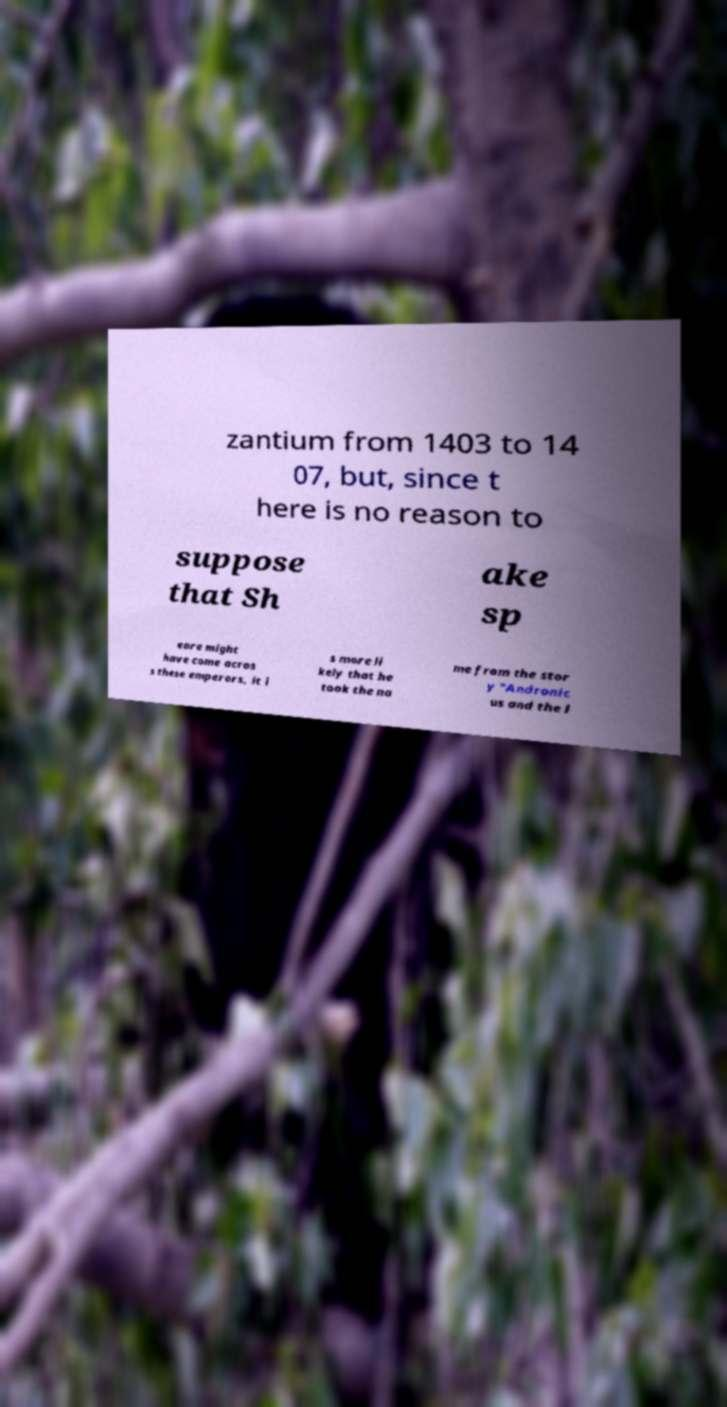What messages or text are displayed in this image? I need them in a readable, typed format. zantium from 1403 to 14 07, but, since t here is no reason to suppose that Sh ake sp eare might have come acros s these emperors, it i s more li kely that he took the na me from the stor y "Andronic us and the l 